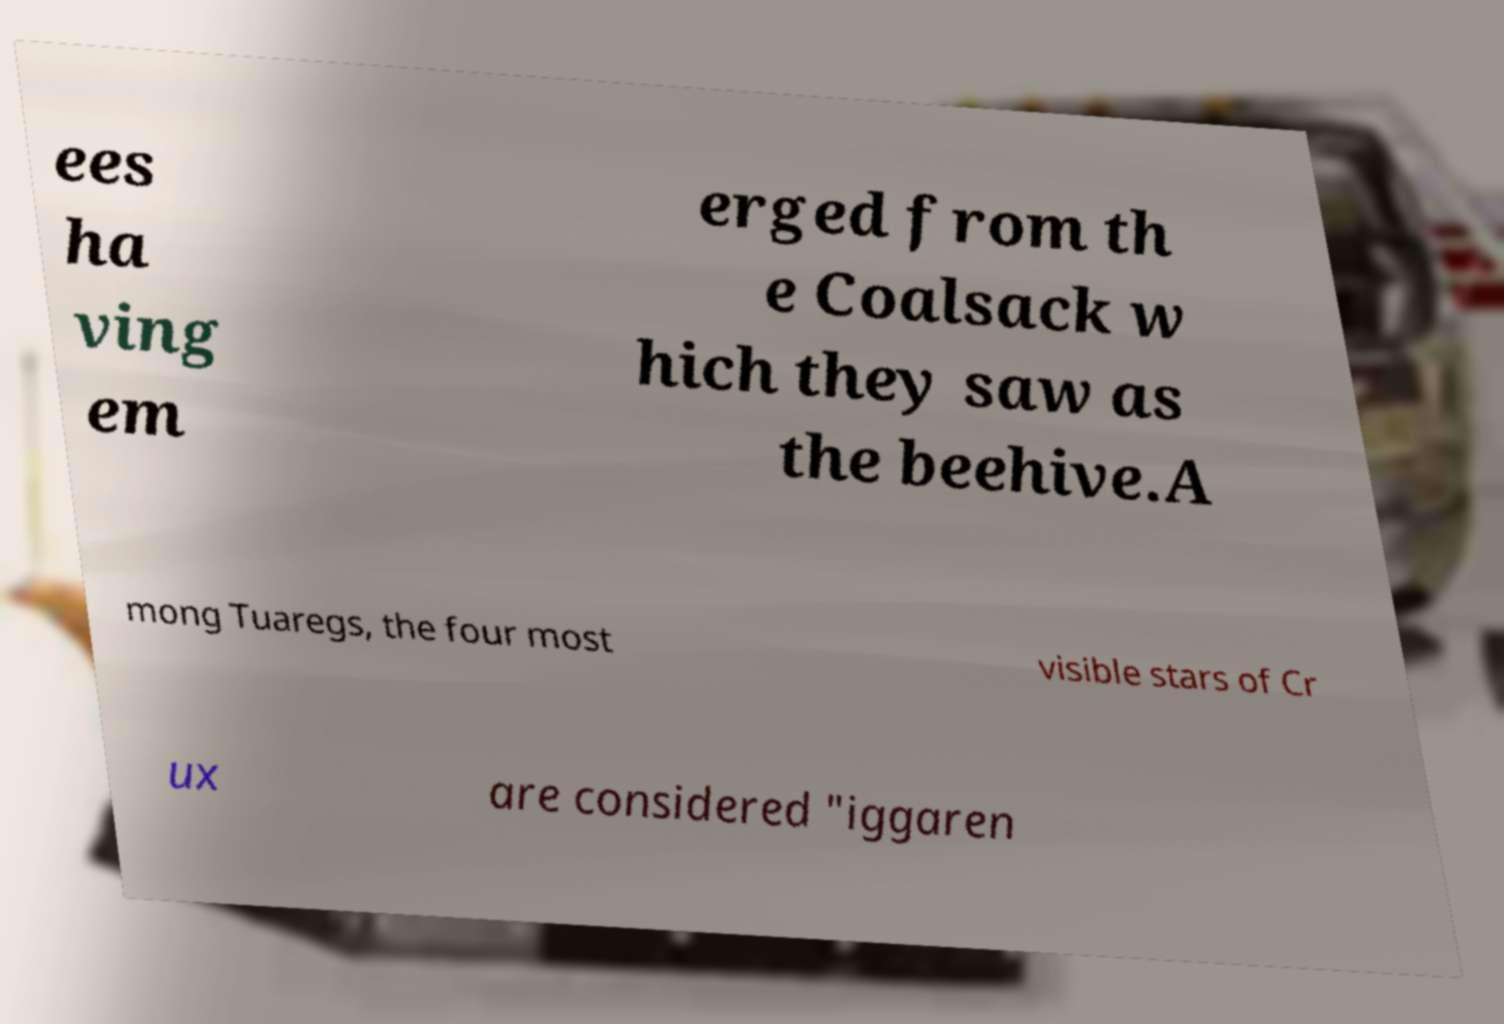Can you accurately transcribe the text from the provided image for me? ees ha ving em erged from th e Coalsack w hich they saw as the beehive.A mong Tuaregs, the four most visible stars of Cr ux are considered "iggaren 